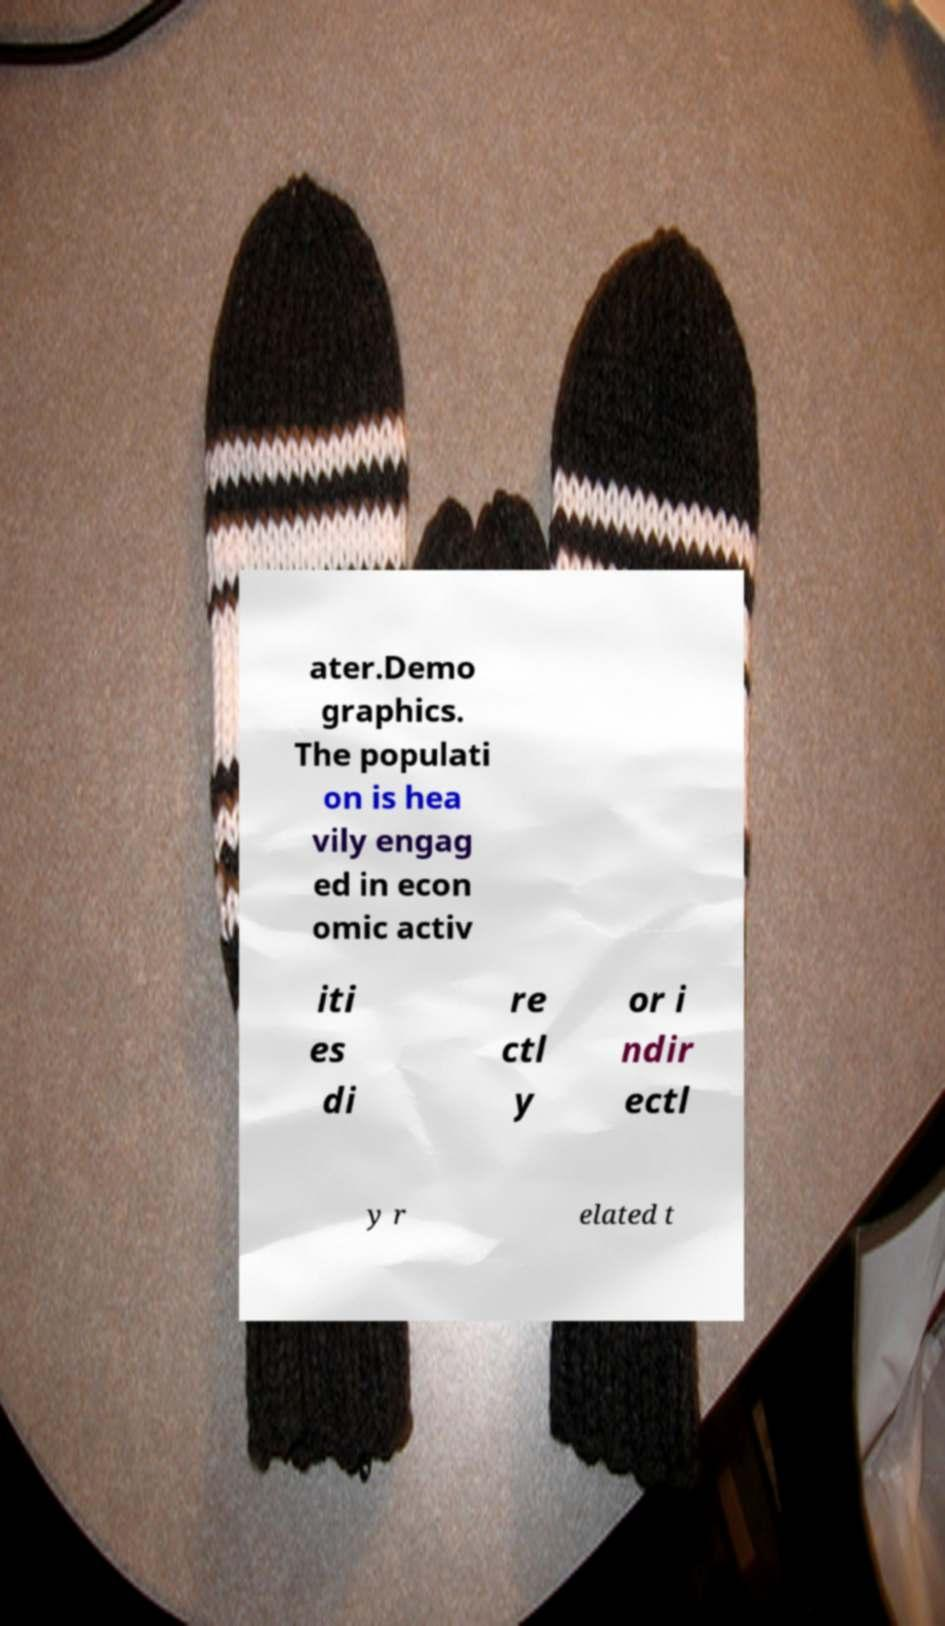I need the written content from this picture converted into text. Can you do that? ater.Demo graphics. The populati on is hea vily engag ed in econ omic activ iti es di re ctl y or i ndir ectl y r elated t 